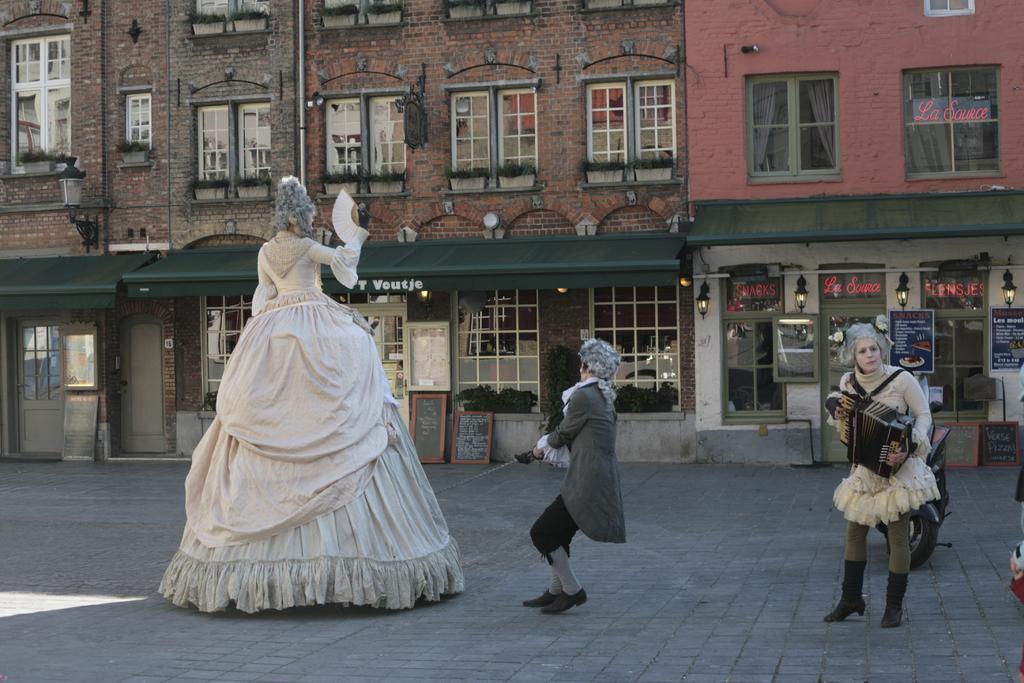In one or two sentences, can you explain what this image depicts? In this image we can see some persons wearing costumes are standing on the ground. One person is holding a sword. One woman is holding a musical instrument in her hands. In the background, we can see a motorcycle parked on the ground, a group of buildings with windows, doors, sign boards with text and some lights. 